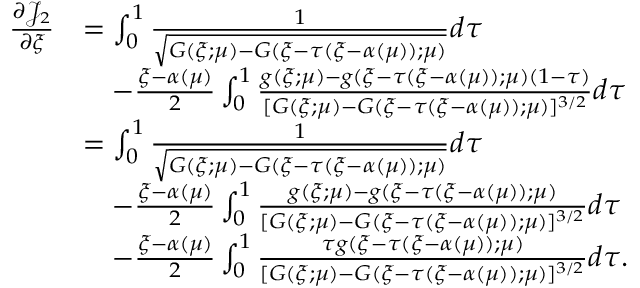<formula> <loc_0><loc_0><loc_500><loc_500>\begin{array} { r l } { \frac { \partial { \mathcal { J } } _ { 2 } } { \partial \xi } } & { = \int _ { 0 } ^ { 1 } \frac { 1 } { \sqrt { G ( \xi ; \mu ) - G ( \xi - \tau ( \xi - \alpha ( \mu ) ) ; \mu ) } } d \tau } \\ & { \quad - \frac { \xi - \alpha ( \mu ) } { 2 } \int _ { 0 } ^ { 1 } \frac { g ( \xi ; \mu ) - g ( \xi - \tau ( \xi - \alpha ( \mu ) ) ; \mu ) ( 1 - \tau ) } { [ G ( \xi ; \mu ) - G ( \xi - \tau ( \xi - \alpha ( \mu ) ) ; \mu ) ] ^ { 3 / 2 } } d \tau } \\ & { = \int _ { 0 } ^ { 1 } \frac { 1 } { \sqrt { G ( \xi ; \mu ) - G ( \xi - \tau ( \xi - \alpha ( \mu ) ) ; \mu ) } } d \tau } \\ & { \quad - \frac { \xi - \alpha ( \mu ) } { 2 } \int _ { 0 } ^ { 1 } \frac { g ( \xi ; \mu ) - g ( \xi - \tau ( \xi - \alpha ( \mu ) ) ; \mu ) } { [ G ( \xi ; \mu ) - G ( \xi - \tau ( \xi - \alpha ( \mu ) ) ; \mu ) ] ^ { 3 / 2 } } d \tau } \\ & { \quad - \frac { \xi - \alpha ( \mu ) } { 2 } \int _ { 0 } ^ { 1 } \frac { \tau g ( \xi - \tau ( \xi - \alpha ( \mu ) ) ; \mu ) } { [ G ( \xi ; \mu ) - G ( \xi - \tau ( \xi - \alpha ( \mu ) ) ; \mu ) ] ^ { 3 / 2 } } d \tau . } \end{array}</formula> 